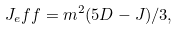Convert formula to latex. <formula><loc_0><loc_0><loc_500><loc_500>J _ { e } f f = m ^ { 2 } ( 5 D - J ) / 3 ,</formula> 